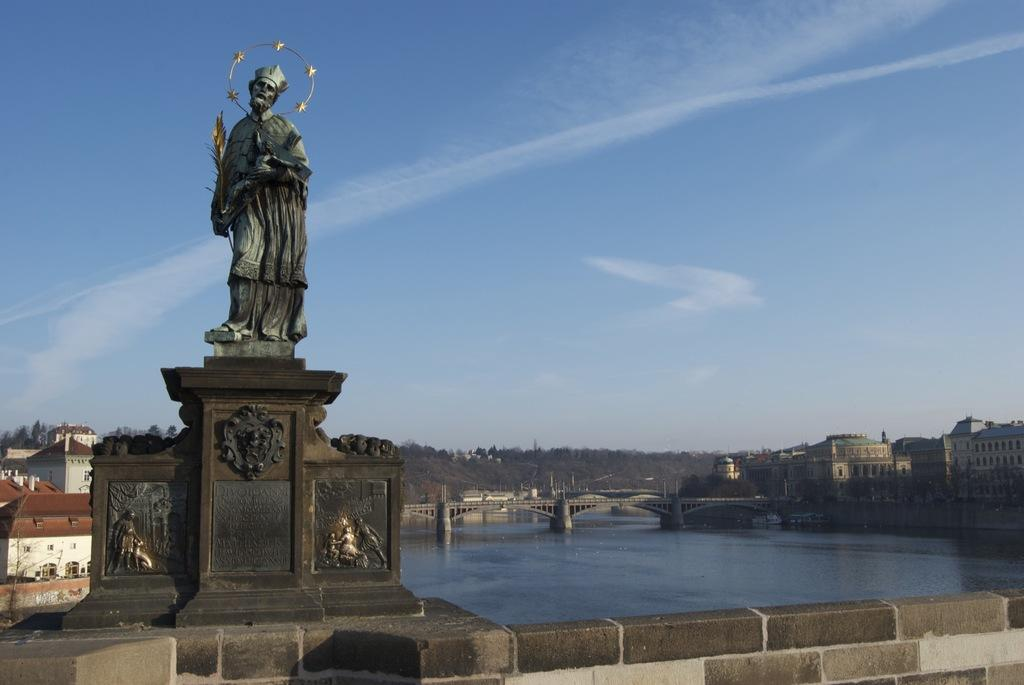What is the main subject of the image? There is a sculpture in the image. What natural feature is present in the image? There is a lake in the image. What can be seen in the background of the image? There are buildings visible in the background of the image. What type of vegetation is present in the image? There are trees present in the image. What type of skirt is the sculpture wearing in the image? The sculpture is not wearing a skirt, as it is an inanimate object and does not have clothing. 